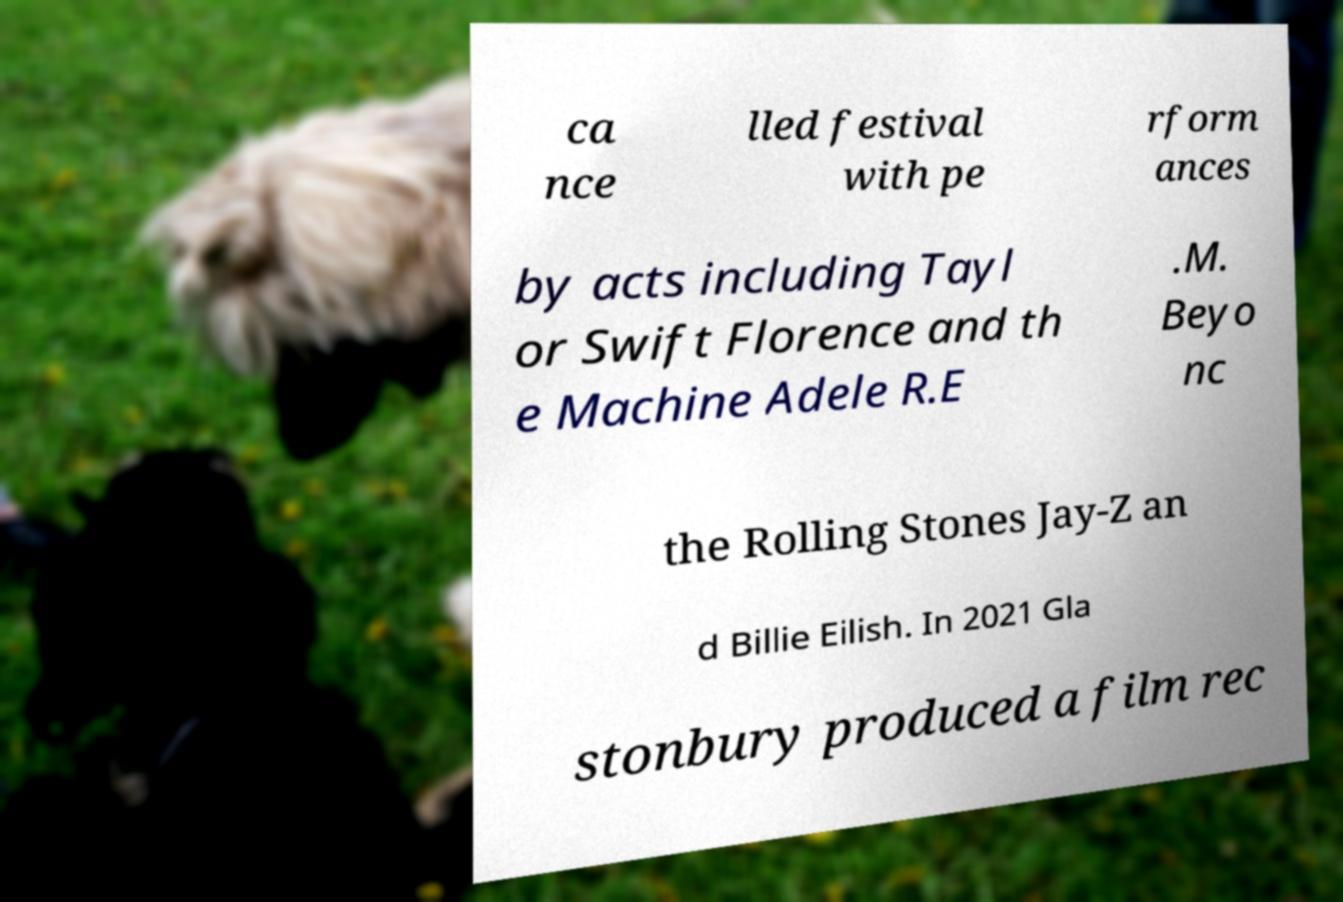Could you extract and type out the text from this image? ca nce lled festival with pe rform ances by acts including Tayl or Swift Florence and th e Machine Adele R.E .M. Beyo nc the Rolling Stones Jay-Z an d Billie Eilish. In 2021 Gla stonbury produced a film rec 